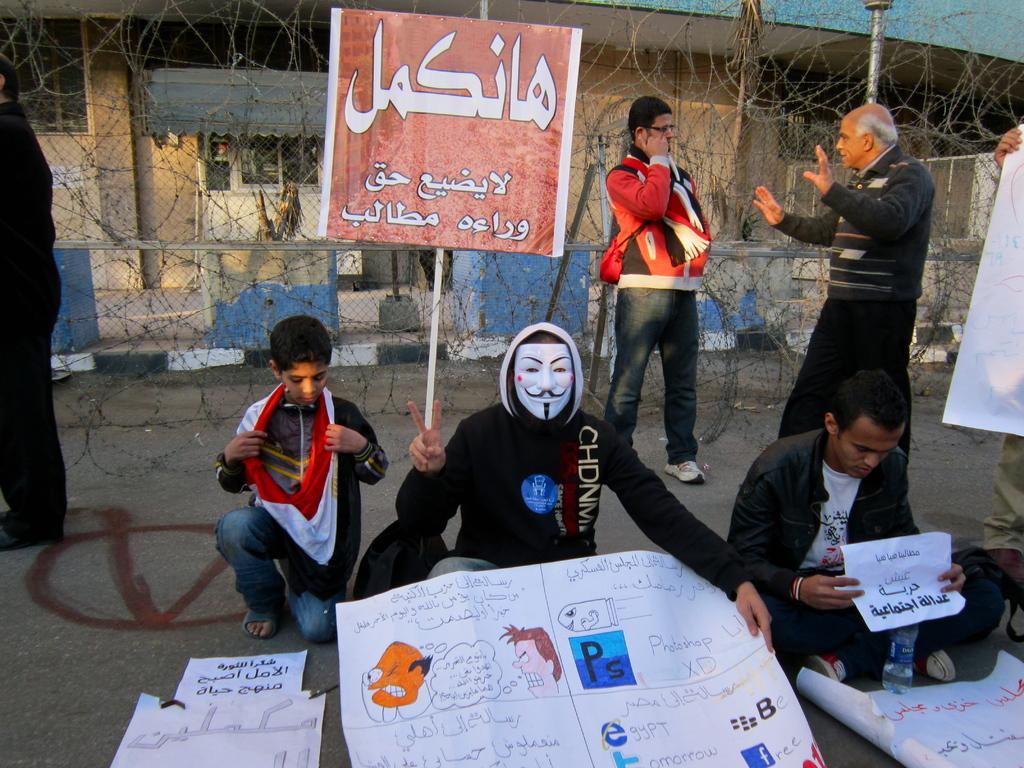Please provide a concise description of this image. In this picture we can see few persons and they are holding posters. He wore a mask and this is a board. In the background we can see a building. 